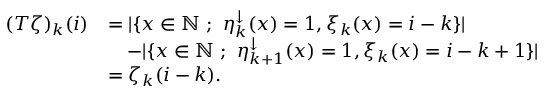Convert formula to latex. <formula><loc_0><loc_0><loc_500><loc_500>\begin{array} { r l } { ( T \zeta ) _ { k } ( i ) } & { = | \{ x \in { \mathbb { N } } \ ; \ \eta _ { k } ^ { \downarrow } ( x ) = 1 , \xi _ { k } ( x ) = i - k \} | } \\ & { \quad - | \{ x \in { \mathbb { N } } \ ; \ \eta _ { k + 1 } ^ { \downarrow } ( x ) = 1 , \xi _ { k } ( x ) = i - k + 1 \} | } \\ & { = \zeta _ { k } ( i - k ) . } \end{array}</formula> 